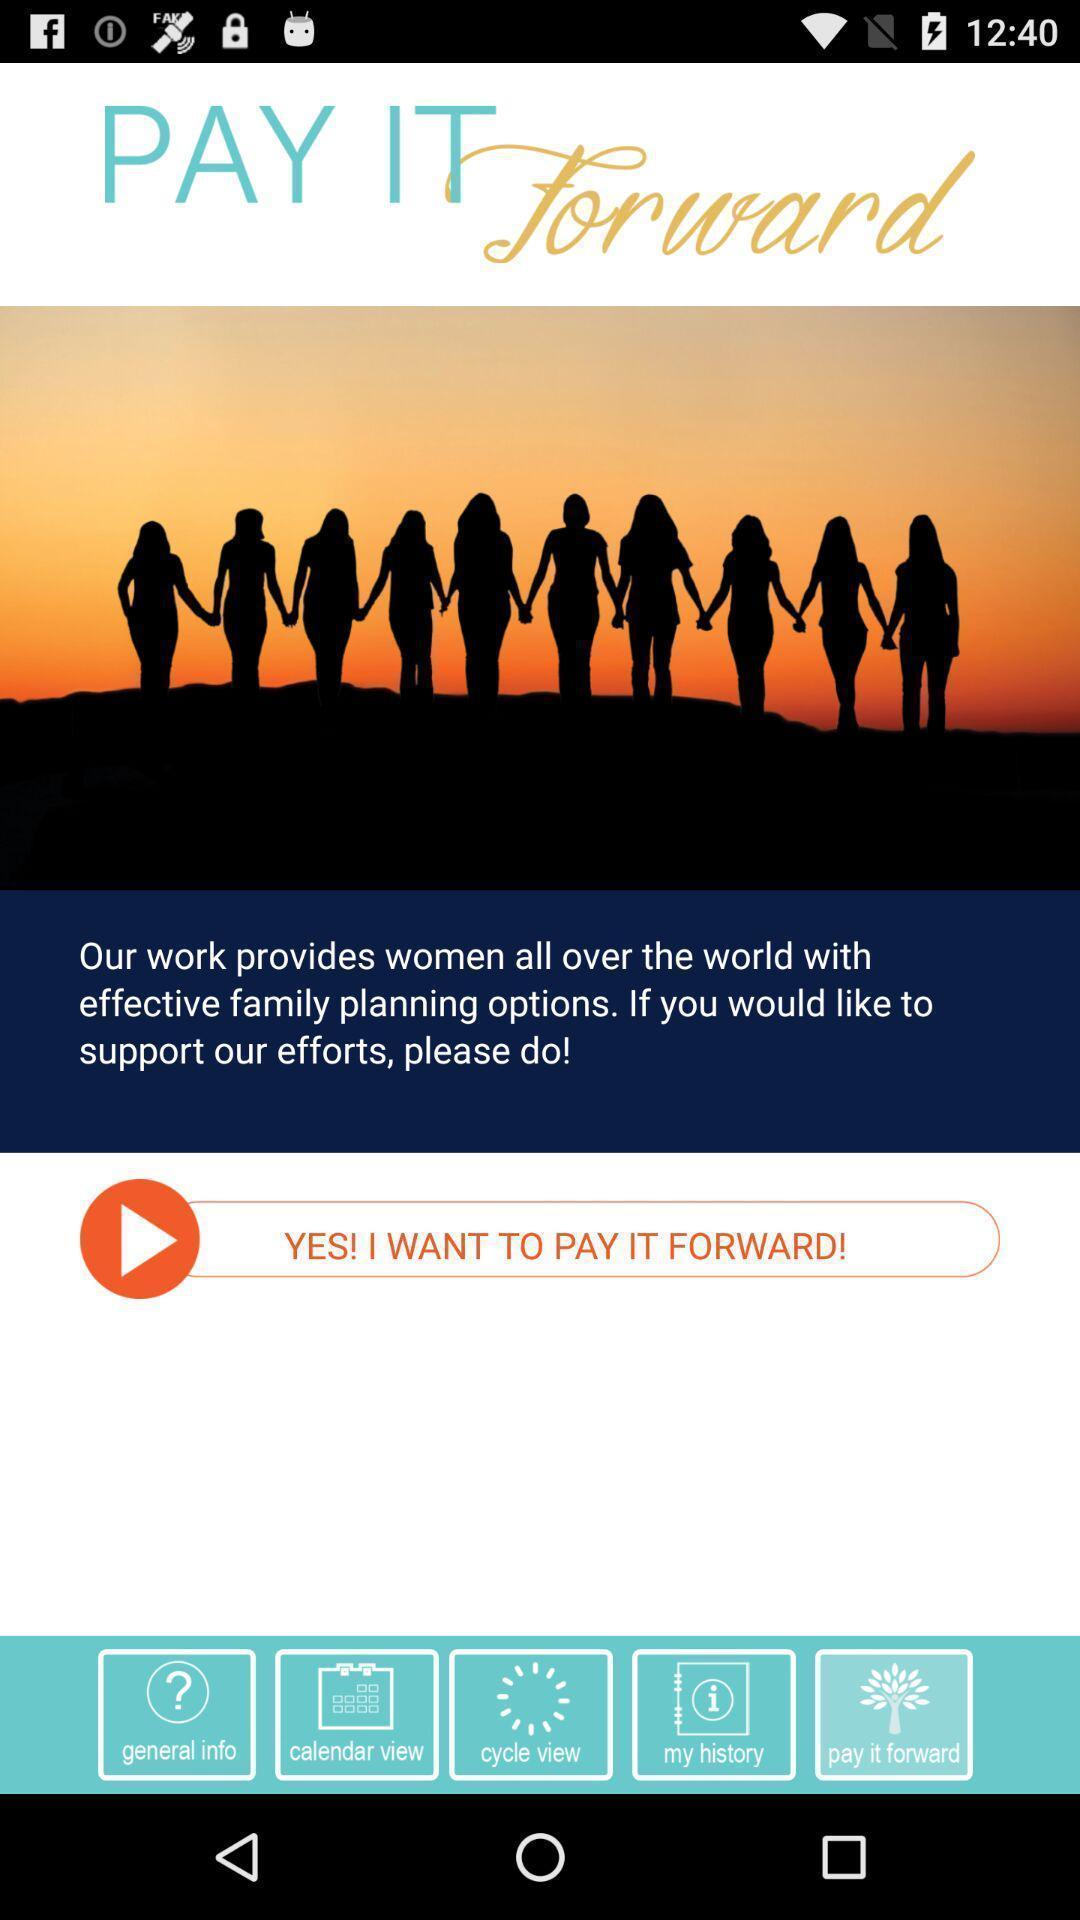What is the overall content of this screenshot? Window displaying a app for family planning. 